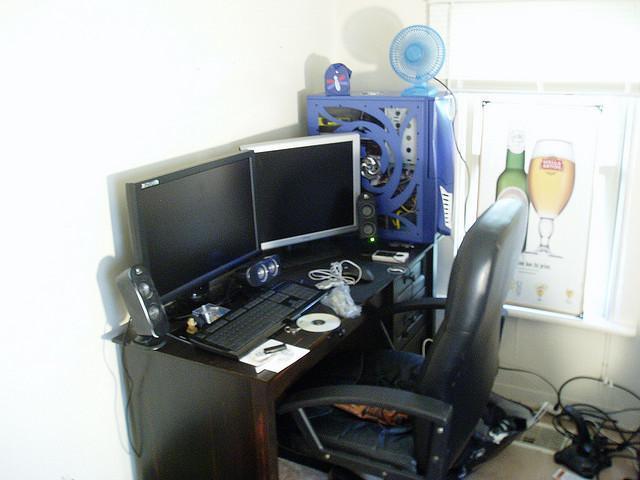How many tvs can you see?
Give a very brief answer. 2. 